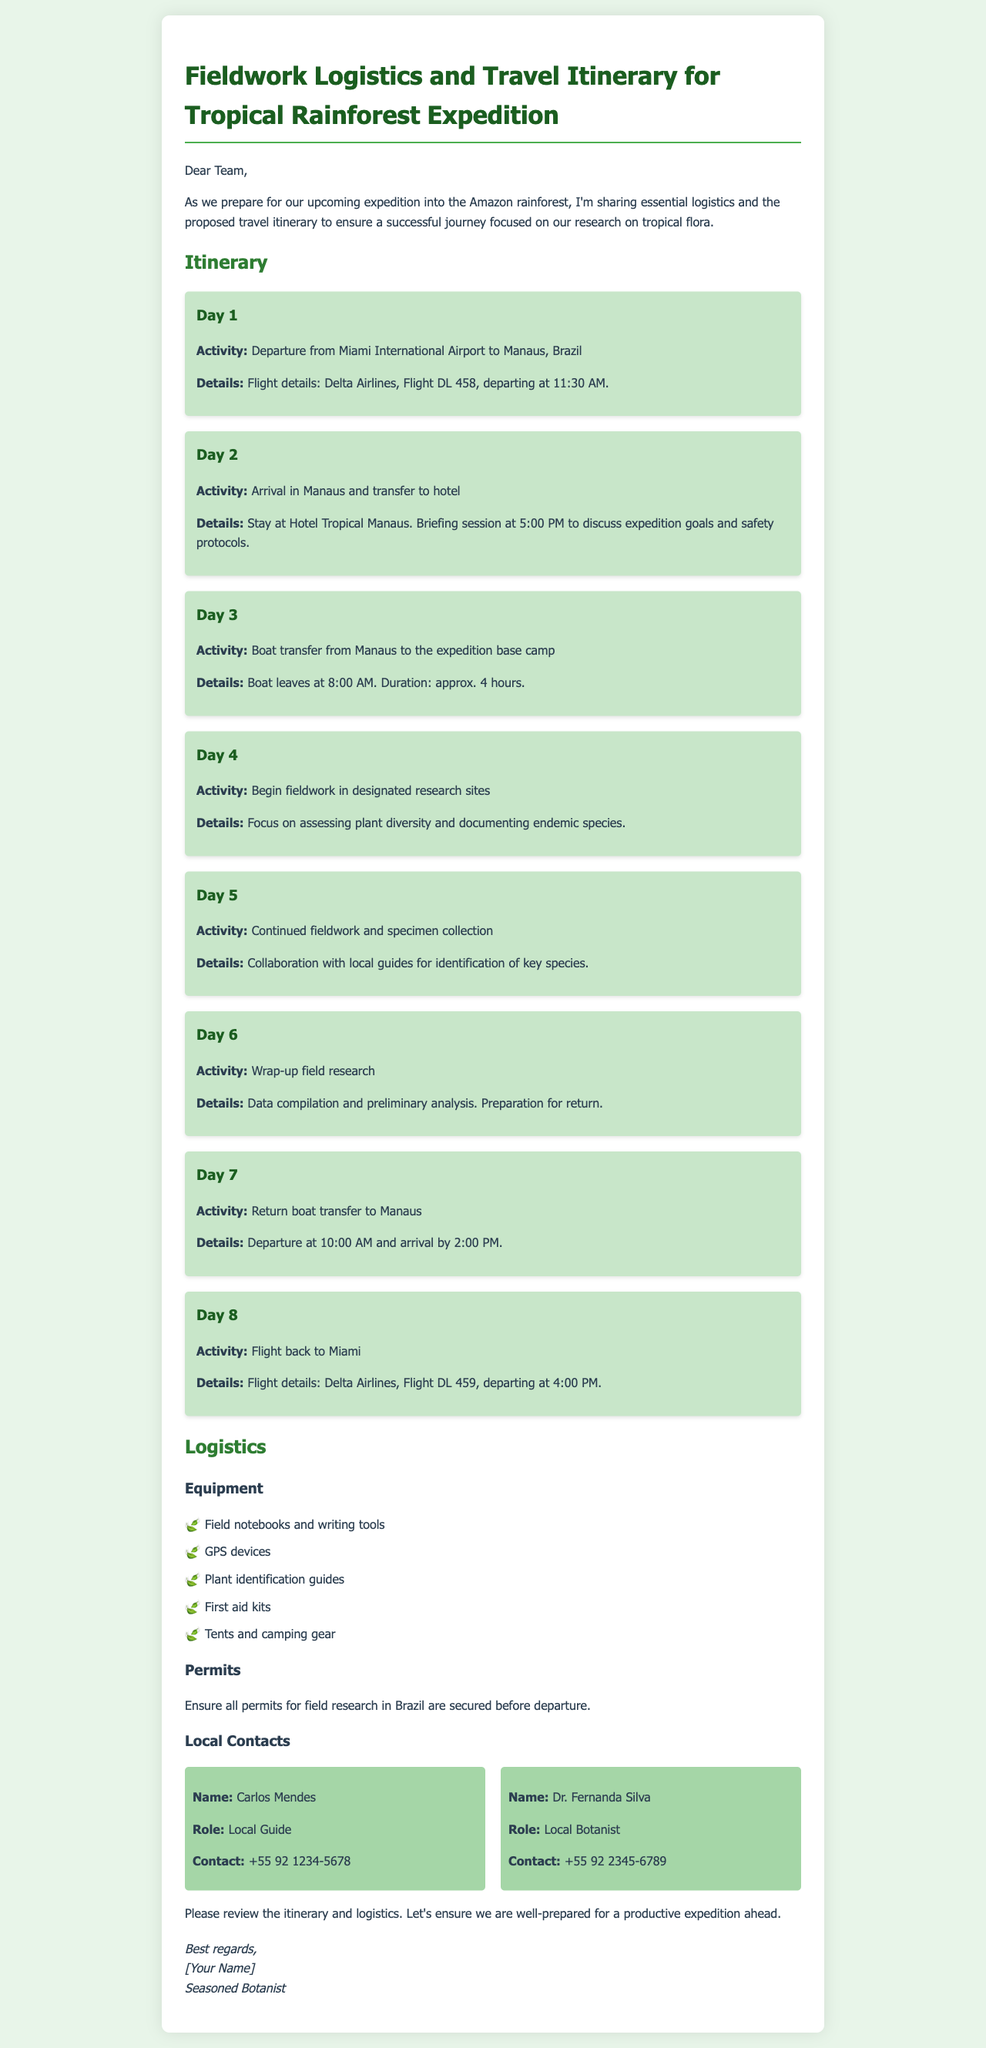What is the departure airport for Day 1? The document states the departure is from Miami International Airport on Day 1.
Answer: Miami International Airport What time does the flight to Manaus leave? The flight leaves at 11:30 AM as indicated in the Day 1 itinerary details.
Answer: 11:30 AM How long is the boat transfer on Day 3? The document specifies that the boat transfer duration is approximately 4 hours.
Answer: approx. 4 hours What activities are planned for Day 4? On Day 4, the expedition involves beginning fieldwork in designated research sites.
Answer: Begin fieldwork Who is the local guide mentioned in the document? The document lists Carlos Mendes as the local guide with his contact information.
Answer: Carlos Mendes What equipment is mentioned for use during the expedition? The document lists various equipment including field notebooks, GPS devices, and first aid kits, among others.
Answer: Field notebooks and writing tools What time will the team return to Manaus on Day 7? The return boat to Manaus is scheduled to leave at 10:00 AM on Day 7.
Answer: 10:00 AM Where is the team staying in Manaus on Day 2? The itinerary states that the team will stay at Hotel Tropical Manaus on Day 2.
Answer: Hotel Tropical Manaus What is the purpose of the briefing on Day 2? The briefing session aims to discuss expedition goals and safety protocols as stated in the itinerary.
Answer: Discuss expedition goals and safety protocols 